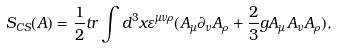Convert formula to latex. <formula><loc_0><loc_0><loc_500><loc_500>S _ { C S } ( A ) = \frac { 1 } { 2 } t r \int d ^ { 3 } x \varepsilon ^ { \mu \nu \rho } ( A _ { \mu } \partial _ { \nu } A _ { \rho } + \frac { 2 } { 3 } g A _ { \mu } A _ { \nu } A _ { \rho } ) ,</formula> 